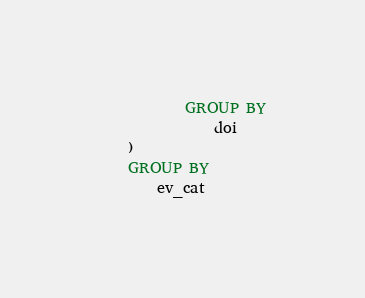<code> <loc_0><loc_0><loc_500><loc_500><_SQL_>            GROUP BY
                doi
    )
    GROUP BY
        ev_cat</code> 